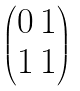<formula> <loc_0><loc_0><loc_500><loc_500>\begin{pmatrix} 0 \, 1 \\ 1 \, 1 \end{pmatrix}</formula> 